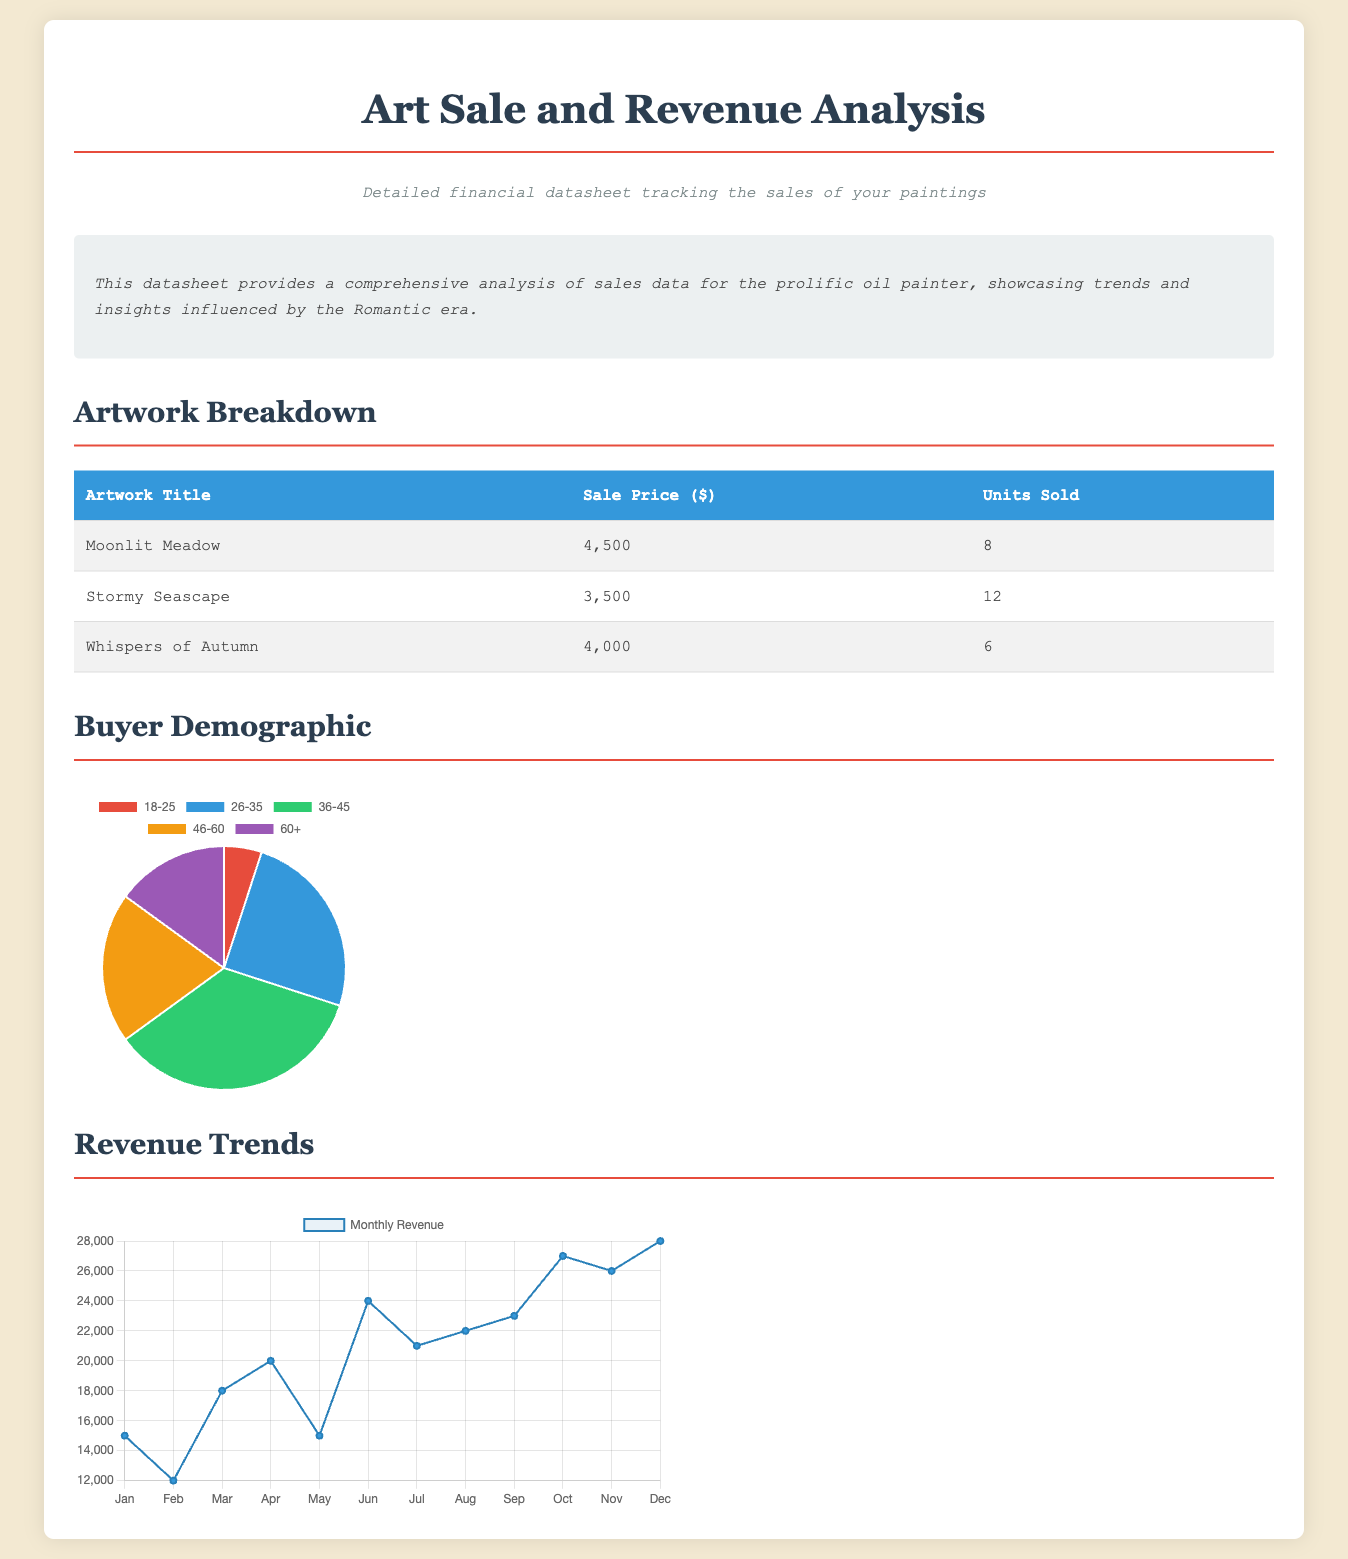What is the title of the artwork with the highest sale price? The highest sale price in the artwork breakdown is for "Moonlit Meadow," which is mentioned in the table.
Answer: Moonlit Meadow How many units of "Stormy Seascape" were sold? The table shows that "Stormy Seascape" had a total of 12 units sold.
Answer: 12 What was the total revenue generated from "Whispers of Autumn"? The revenue for "Whispers of Autumn" is calculated by multiplying the sale price ($4000) by the units sold (6).
Answer: $24000 Which age group has the highest percentage in the buyer demographic? According to the pie chart on buyer demographics, the age group 36-45 has the highest percentage among the listed groups.
Answer: 36-45 What was the monthly revenue in June? The line graph displays that the monthly revenue for June was $24000.
Answer: $24000 How many different age groups are represented in the buyer demographic chart? The chart presents five distinct age groups.
Answer: 5 What is the trend of monthly revenue from January to December? The line graph indicates that monthly revenue has been increasing over the course of the year.
Answer: Increasing Which artwork has the lowest sale price? The table reveals that "Stormy Seascape" has the lowest sale price of the listed artworks.
Answer: Stormy Seascape What color is used for the background of the revenue trend chart? The chart's background color is a light shade of blue, specifically noted as rgba(41, 128, 185, 0.1).
Answer: Light blue 